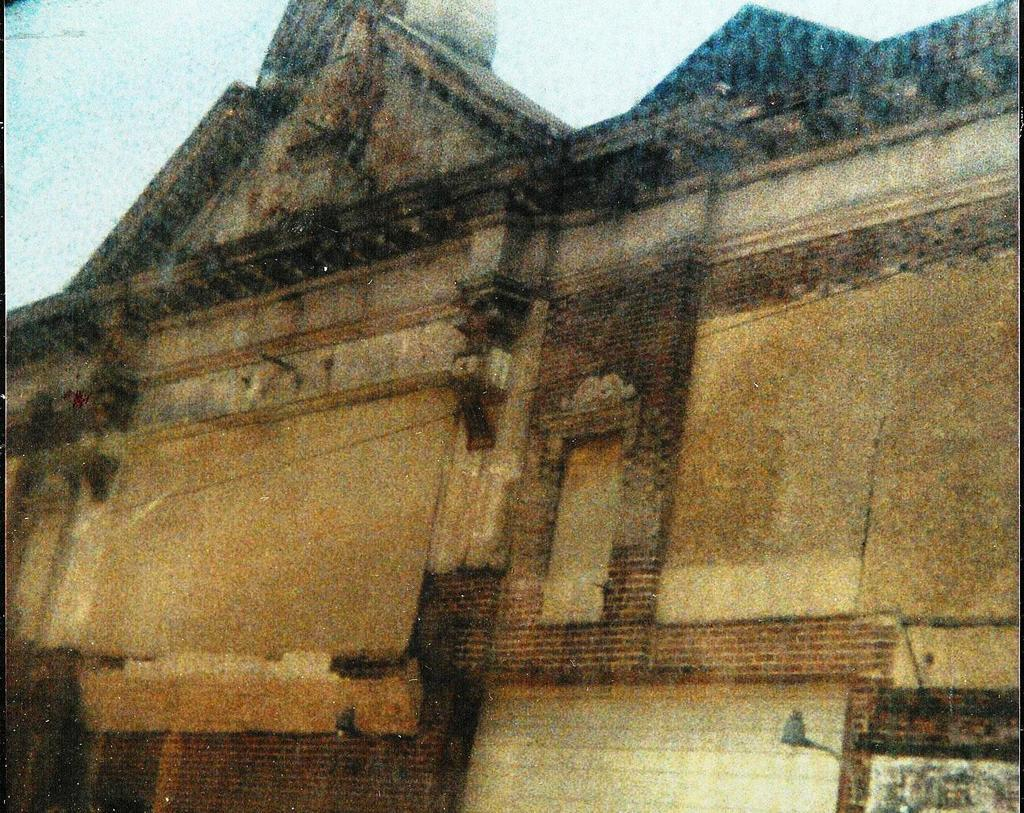What type of structure is in the image? There is an old building in the image. What is located at the bottom of the image? There is a street light at the bottom of the image. What can be seen at the top of the image? The sky is visible at the top of the image. Can you describe the nature of the image? The image might be a photo frame. What type of vegetable can be smelled in the image? There is no vegetable present in the image, and therefore no scent can be detected. 